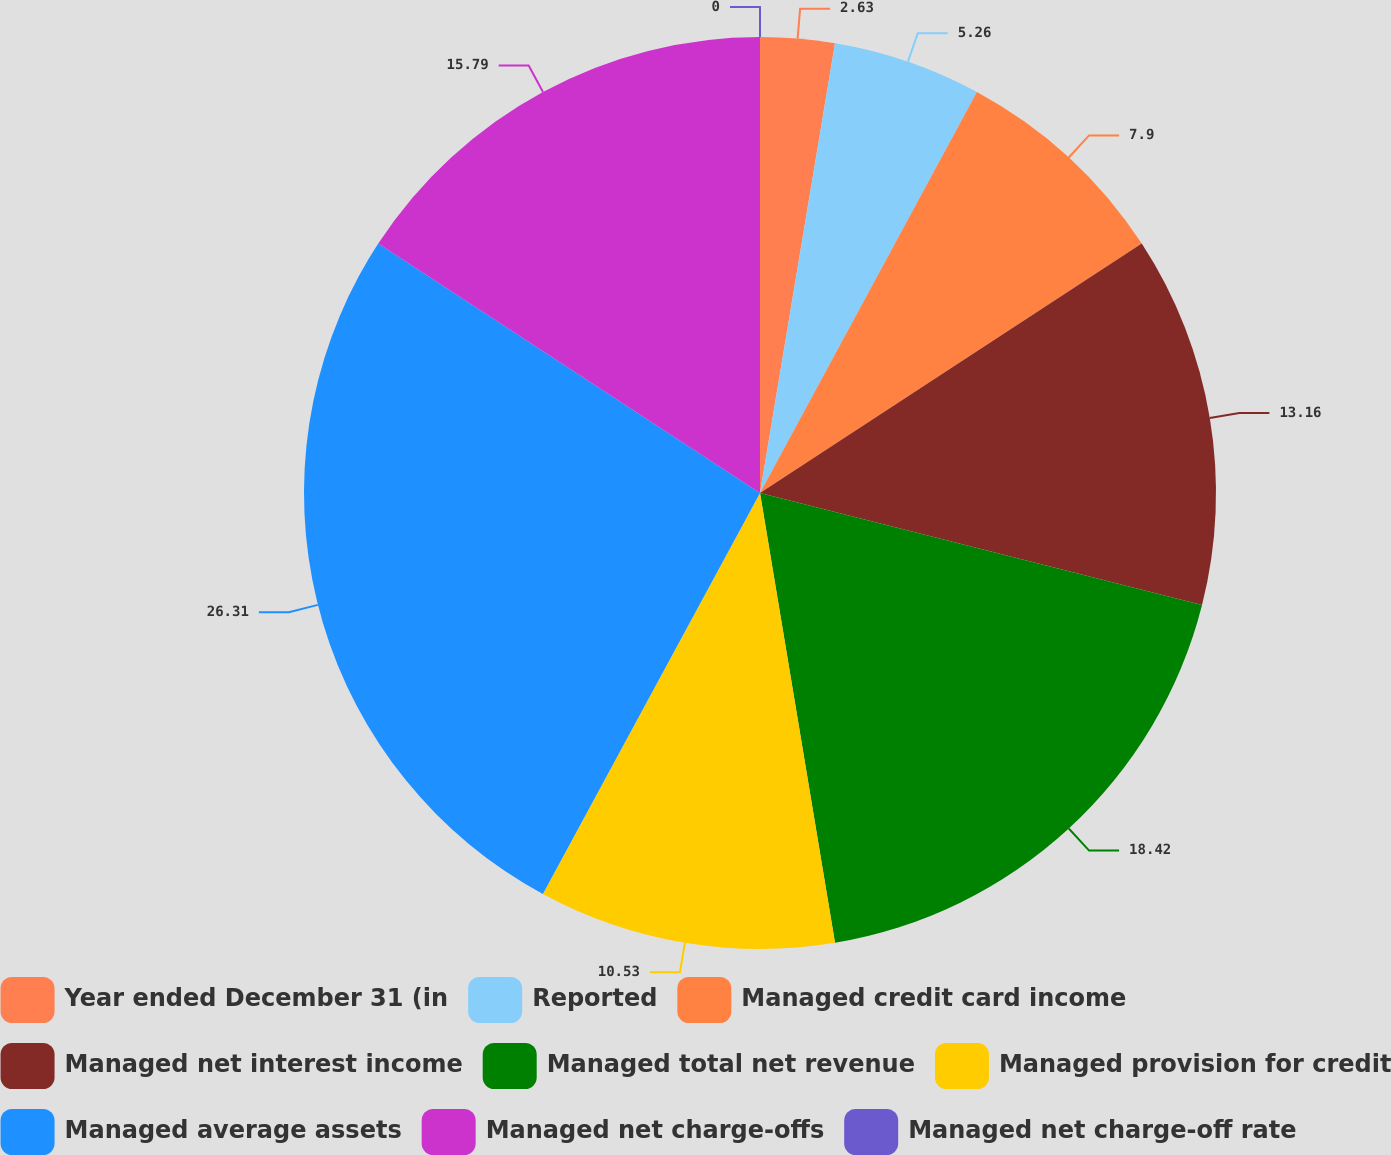Convert chart. <chart><loc_0><loc_0><loc_500><loc_500><pie_chart><fcel>Year ended December 31 (in<fcel>Reported<fcel>Managed credit card income<fcel>Managed net interest income<fcel>Managed total net revenue<fcel>Managed provision for credit<fcel>Managed average assets<fcel>Managed net charge-offs<fcel>Managed net charge-off rate<nl><fcel>2.63%<fcel>5.26%<fcel>7.9%<fcel>13.16%<fcel>18.42%<fcel>10.53%<fcel>26.31%<fcel>15.79%<fcel>0.0%<nl></chart> 